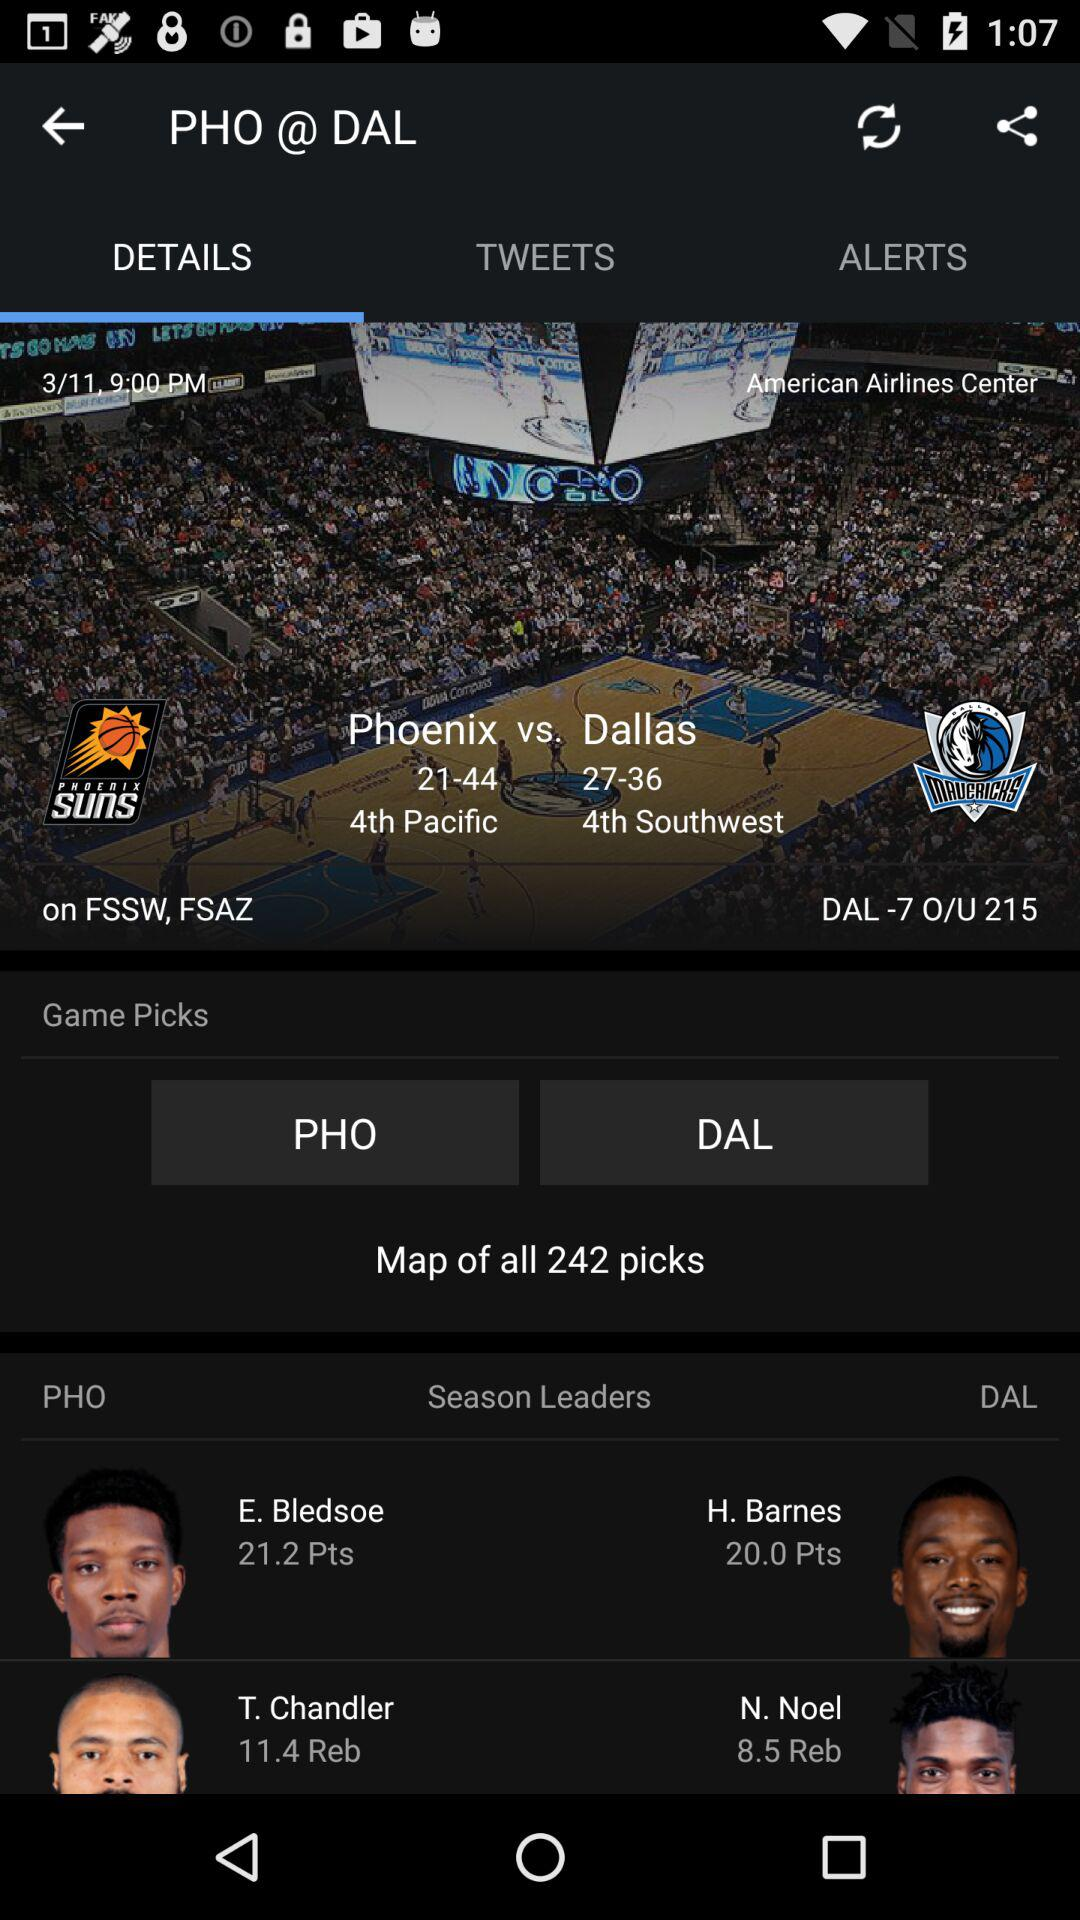Which tab is selected? The selected tab is "Details". 